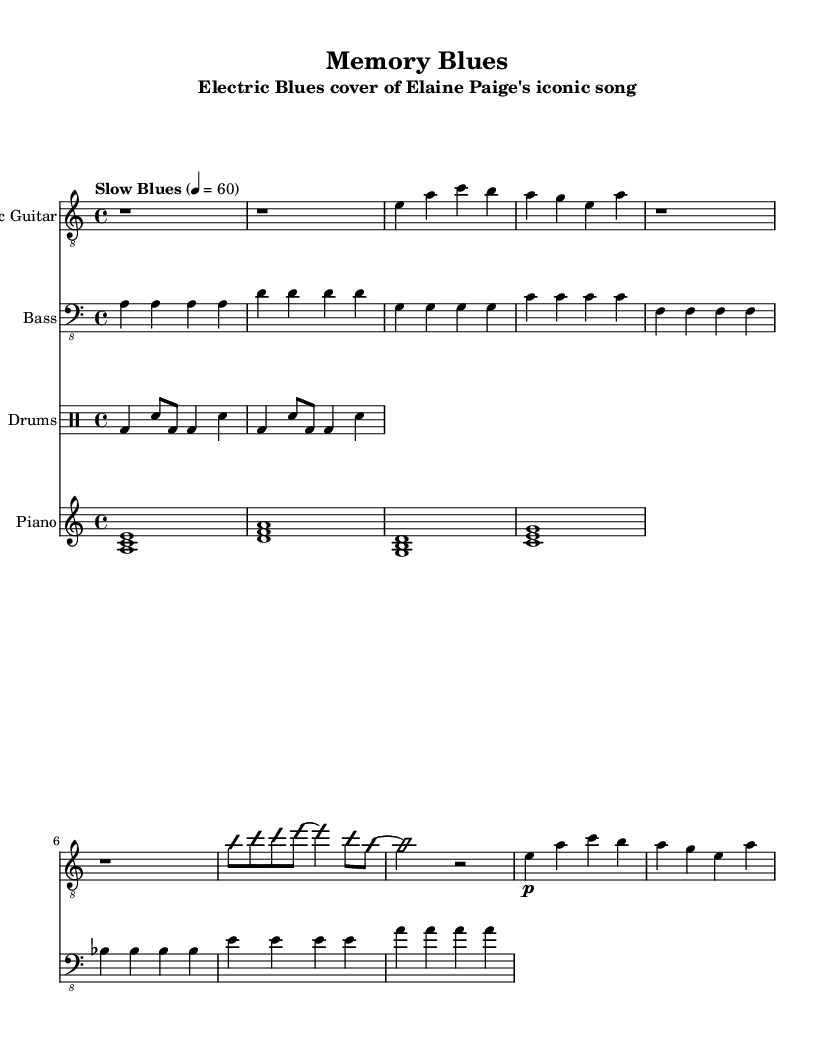What is the key signature of this music? The key signature is A minor, which has no sharps or flats.
Answer: A minor What is the time signature of this music? The time signature is 4/4, indicating there are four beats per measure.
Answer: 4/4 What is the tempo marking for this piece? The tempo marking is "Slow Blues", which suggests a relaxed and deliberate pace.
Answer: Slow Blues How many measures are there in the guitar solo? The guitar solo consists of 2 measures as indicated by the notation.
Answer: 2 measures What instruments are featured in this arrangement? The arrangement features electric guitar, bass, drums, and piano.
Answer: Electric guitar, bass, drums, piano Which style of music is this piece primarily associated with? The piece is primarily associated with Electric Blues, as indicated by the instrumentation and style markings.
Answer: Electric Blues What is the first chord played by the piano? The first chord played by the piano is A minor, played as a triad in the left hand.
Answer: A minor 